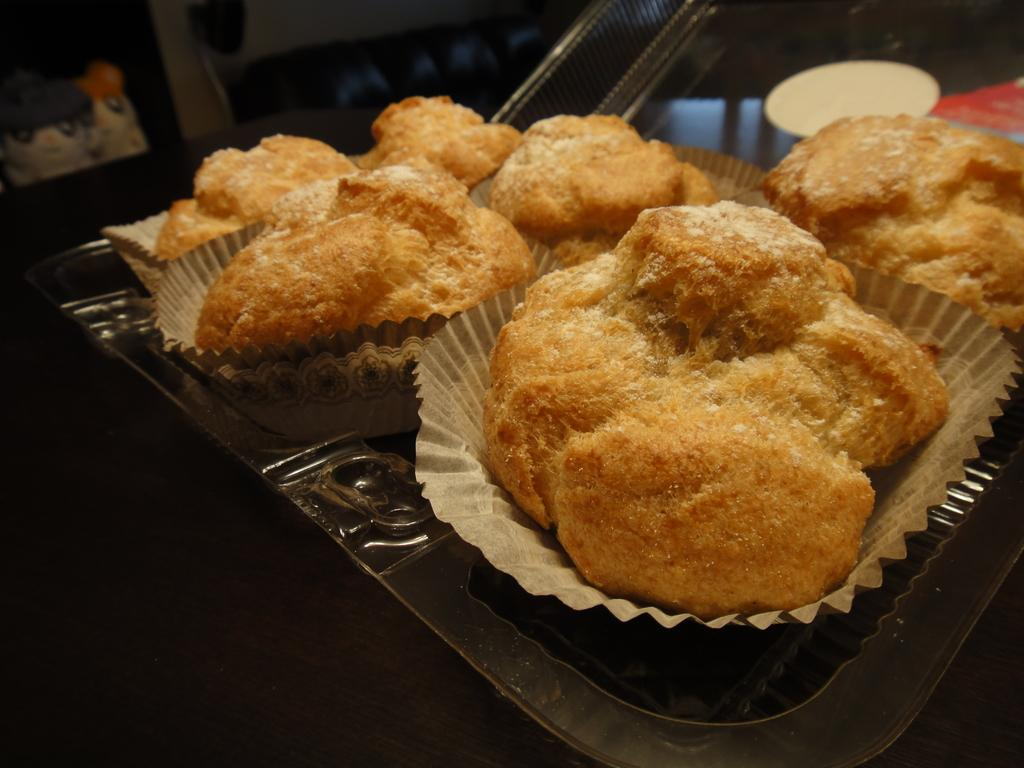What is present on the tray in the image? There are food items in a tray in the image. What can be seen in the background of the image? There is a sofa, toys, and a wall in the background of the image. What is the color of the object in the image? There is a white-colored object in the image. What is the title of the book that the person is reading on the sofa in the image? There is no book or person reading in the image; it only shows food items in a tray, toys, a sofa, and a wall in the background. 